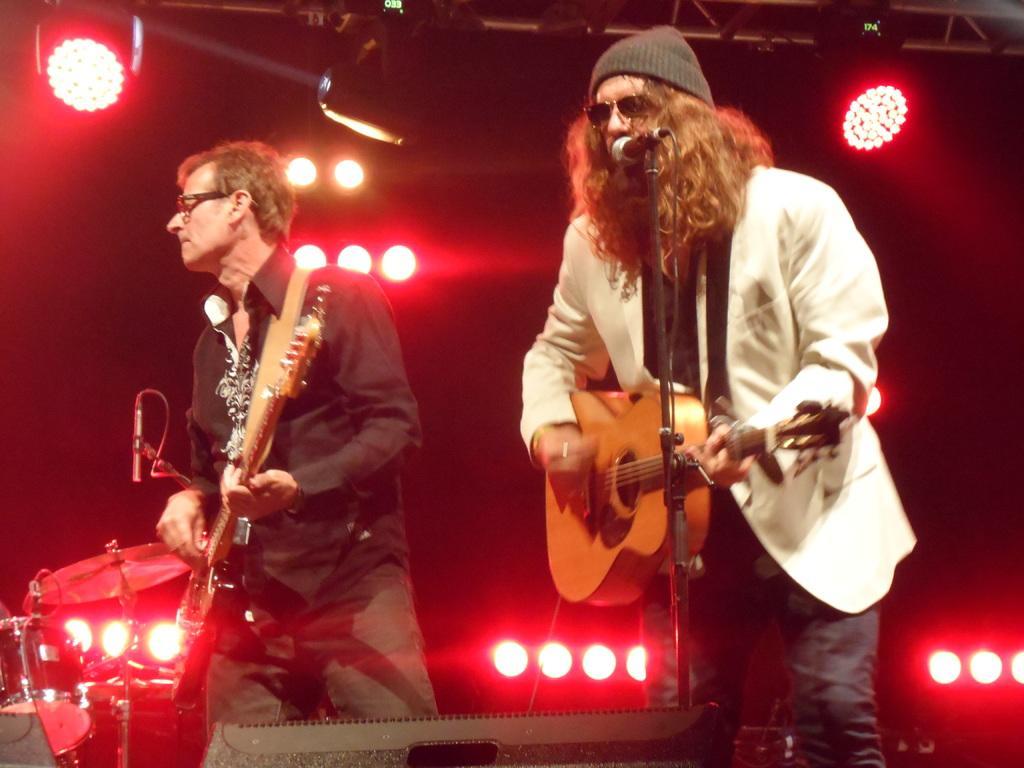Can you describe this image briefly? There are two people. They are playing a musical instruments. On the right side we have a white color shirt person. He's wearing a cap. 